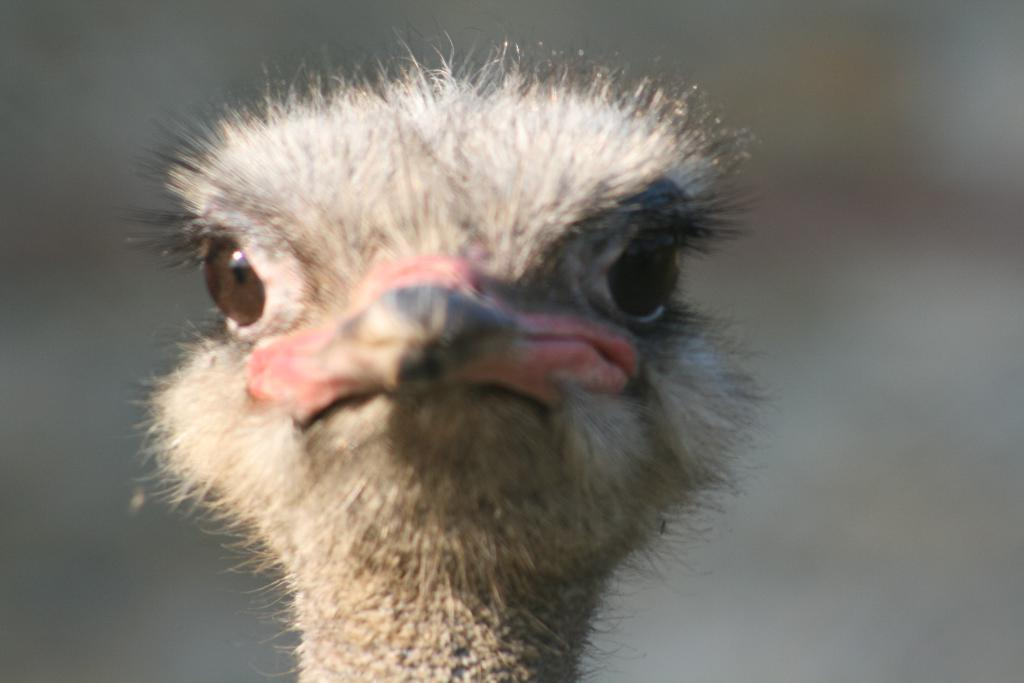What type of animal is in the image? There is an animal in the image, but the specific type cannot be determined from the provided facts. What part of the animal is visible in the image? The head part of the animal is visible in the image. What feature is present on the animal's face? The animal has a beak. How would you describe the background of the image? The background of the animal is blurred. In which direction is the snail moving in the image? There is no snail present in the image, so it is not possible to determine the direction in which it might be moving. 